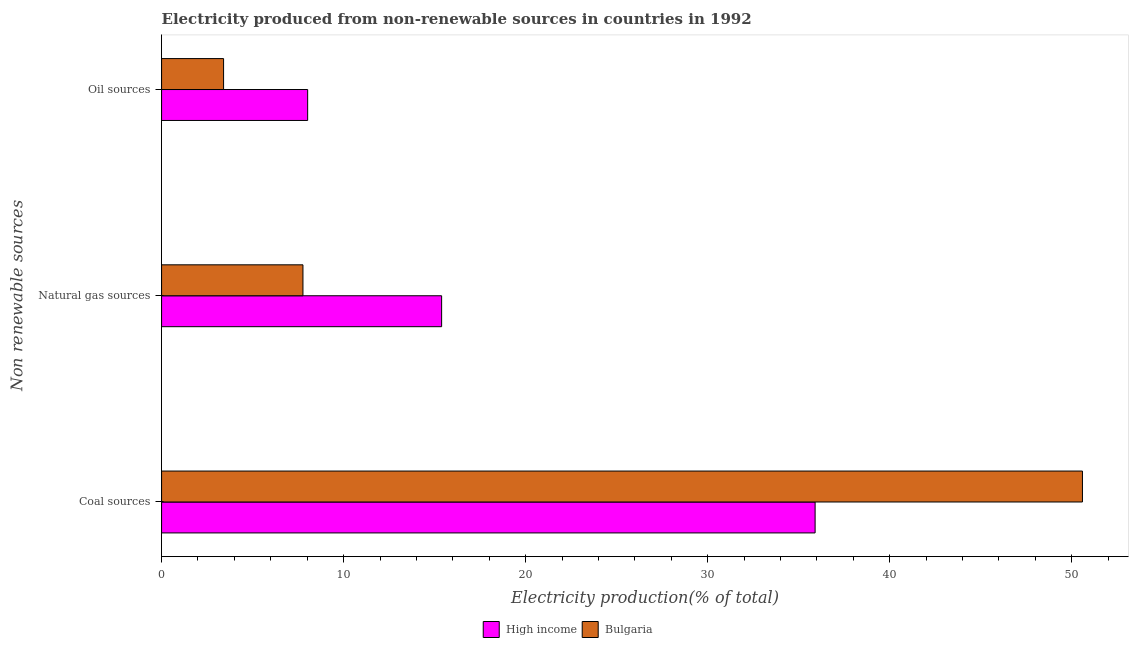How many different coloured bars are there?
Ensure brevity in your answer.  2. Are the number of bars per tick equal to the number of legend labels?
Offer a very short reply. Yes. How many bars are there on the 1st tick from the top?
Provide a short and direct response. 2. How many bars are there on the 3rd tick from the bottom?
Provide a succinct answer. 2. What is the label of the 2nd group of bars from the top?
Keep it short and to the point. Natural gas sources. What is the percentage of electricity produced by coal in High income?
Ensure brevity in your answer.  35.91. Across all countries, what is the maximum percentage of electricity produced by natural gas?
Offer a terse response. 15.39. Across all countries, what is the minimum percentage of electricity produced by coal?
Give a very brief answer. 35.91. What is the total percentage of electricity produced by oil sources in the graph?
Make the answer very short. 11.43. What is the difference between the percentage of electricity produced by coal in High income and that in Bulgaria?
Your response must be concise. -14.69. What is the difference between the percentage of electricity produced by oil sources in High income and the percentage of electricity produced by coal in Bulgaria?
Make the answer very short. -42.57. What is the average percentage of electricity produced by oil sources per country?
Your response must be concise. 5.72. What is the difference between the percentage of electricity produced by oil sources and percentage of electricity produced by natural gas in Bulgaria?
Give a very brief answer. -4.36. In how many countries, is the percentage of electricity produced by coal greater than 36 %?
Provide a short and direct response. 1. What is the ratio of the percentage of electricity produced by natural gas in High income to that in Bulgaria?
Ensure brevity in your answer.  1.98. Is the percentage of electricity produced by natural gas in High income less than that in Bulgaria?
Provide a short and direct response. No. Is the difference between the percentage of electricity produced by coal in Bulgaria and High income greater than the difference between the percentage of electricity produced by oil sources in Bulgaria and High income?
Keep it short and to the point. Yes. What is the difference between the highest and the second highest percentage of electricity produced by coal?
Provide a succinct answer. 14.69. What is the difference between the highest and the lowest percentage of electricity produced by oil sources?
Keep it short and to the point. 4.62. Is the sum of the percentage of electricity produced by natural gas in High income and Bulgaria greater than the maximum percentage of electricity produced by coal across all countries?
Make the answer very short. No. What does the 2nd bar from the top in Oil sources represents?
Make the answer very short. High income. Is it the case that in every country, the sum of the percentage of electricity produced by coal and percentage of electricity produced by natural gas is greater than the percentage of electricity produced by oil sources?
Offer a terse response. Yes. How many bars are there?
Your answer should be very brief. 6. How many countries are there in the graph?
Offer a terse response. 2. Are the values on the major ticks of X-axis written in scientific E-notation?
Offer a terse response. No. Does the graph contain any zero values?
Give a very brief answer. No. How many legend labels are there?
Offer a very short reply. 2. How are the legend labels stacked?
Provide a short and direct response. Horizontal. What is the title of the graph?
Ensure brevity in your answer.  Electricity produced from non-renewable sources in countries in 1992. Does "Curacao" appear as one of the legend labels in the graph?
Ensure brevity in your answer.  No. What is the label or title of the X-axis?
Your answer should be compact. Electricity production(% of total). What is the label or title of the Y-axis?
Your answer should be very brief. Non renewable sources. What is the Electricity production(% of total) in High income in Coal sources?
Your answer should be compact. 35.91. What is the Electricity production(% of total) of Bulgaria in Coal sources?
Make the answer very short. 50.59. What is the Electricity production(% of total) in High income in Natural gas sources?
Offer a very short reply. 15.39. What is the Electricity production(% of total) of Bulgaria in Natural gas sources?
Your response must be concise. 7.77. What is the Electricity production(% of total) in High income in Oil sources?
Your response must be concise. 8.03. What is the Electricity production(% of total) in Bulgaria in Oil sources?
Provide a short and direct response. 3.41. Across all Non renewable sources, what is the maximum Electricity production(% of total) of High income?
Your answer should be very brief. 35.91. Across all Non renewable sources, what is the maximum Electricity production(% of total) in Bulgaria?
Your answer should be compact. 50.59. Across all Non renewable sources, what is the minimum Electricity production(% of total) in High income?
Make the answer very short. 8.03. Across all Non renewable sources, what is the minimum Electricity production(% of total) of Bulgaria?
Offer a very short reply. 3.41. What is the total Electricity production(% of total) of High income in the graph?
Keep it short and to the point. 59.32. What is the total Electricity production(% of total) in Bulgaria in the graph?
Your answer should be compact. 61.77. What is the difference between the Electricity production(% of total) in High income in Coal sources and that in Natural gas sources?
Make the answer very short. 20.52. What is the difference between the Electricity production(% of total) in Bulgaria in Coal sources and that in Natural gas sources?
Offer a terse response. 42.83. What is the difference between the Electricity production(% of total) in High income in Coal sources and that in Oil sources?
Offer a terse response. 27.88. What is the difference between the Electricity production(% of total) of Bulgaria in Coal sources and that in Oil sources?
Your answer should be compact. 47.19. What is the difference between the Electricity production(% of total) in High income in Natural gas sources and that in Oil sources?
Your answer should be very brief. 7.36. What is the difference between the Electricity production(% of total) of Bulgaria in Natural gas sources and that in Oil sources?
Keep it short and to the point. 4.36. What is the difference between the Electricity production(% of total) of High income in Coal sources and the Electricity production(% of total) of Bulgaria in Natural gas sources?
Your response must be concise. 28.14. What is the difference between the Electricity production(% of total) of High income in Coal sources and the Electricity production(% of total) of Bulgaria in Oil sources?
Make the answer very short. 32.5. What is the difference between the Electricity production(% of total) of High income in Natural gas sources and the Electricity production(% of total) of Bulgaria in Oil sources?
Make the answer very short. 11.98. What is the average Electricity production(% of total) of High income per Non renewable sources?
Make the answer very short. 19.77. What is the average Electricity production(% of total) in Bulgaria per Non renewable sources?
Make the answer very short. 20.59. What is the difference between the Electricity production(% of total) in High income and Electricity production(% of total) in Bulgaria in Coal sources?
Your answer should be very brief. -14.69. What is the difference between the Electricity production(% of total) of High income and Electricity production(% of total) of Bulgaria in Natural gas sources?
Make the answer very short. 7.62. What is the difference between the Electricity production(% of total) in High income and Electricity production(% of total) in Bulgaria in Oil sources?
Provide a succinct answer. 4.62. What is the ratio of the Electricity production(% of total) of High income in Coal sources to that in Natural gas sources?
Your response must be concise. 2.33. What is the ratio of the Electricity production(% of total) of Bulgaria in Coal sources to that in Natural gas sources?
Offer a terse response. 6.51. What is the ratio of the Electricity production(% of total) in High income in Coal sources to that in Oil sources?
Offer a very short reply. 4.47. What is the ratio of the Electricity production(% of total) of Bulgaria in Coal sources to that in Oil sources?
Offer a terse response. 14.85. What is the ratio of the Electricity production(% of total) in High income in Natural gas sources to that in Oil sources?
Your answer should be very brief. 1.92. What is the ratio of the Electricity production(% of total) of Bulgaria in Natural gas sources to that in Oil sources?
Your answer should be compact. 2.28. What is the difference between the highest and the second highest Electricity production(% of total) of High income?
Give a very brief answer. 20.52. What is the difference between the highest and the second highest Electricity production(% of total) of Bulgaria?
Keep it short and to the point. 42.83. What is the difference between the highest and the lowest Electricity production(% of total) in High income?
Make the answer very short. 27.88. What is the difference between the highest and the lowest Electricity production(% of total) in Bulgaria?
Your answer should be very brief. 47.19. 